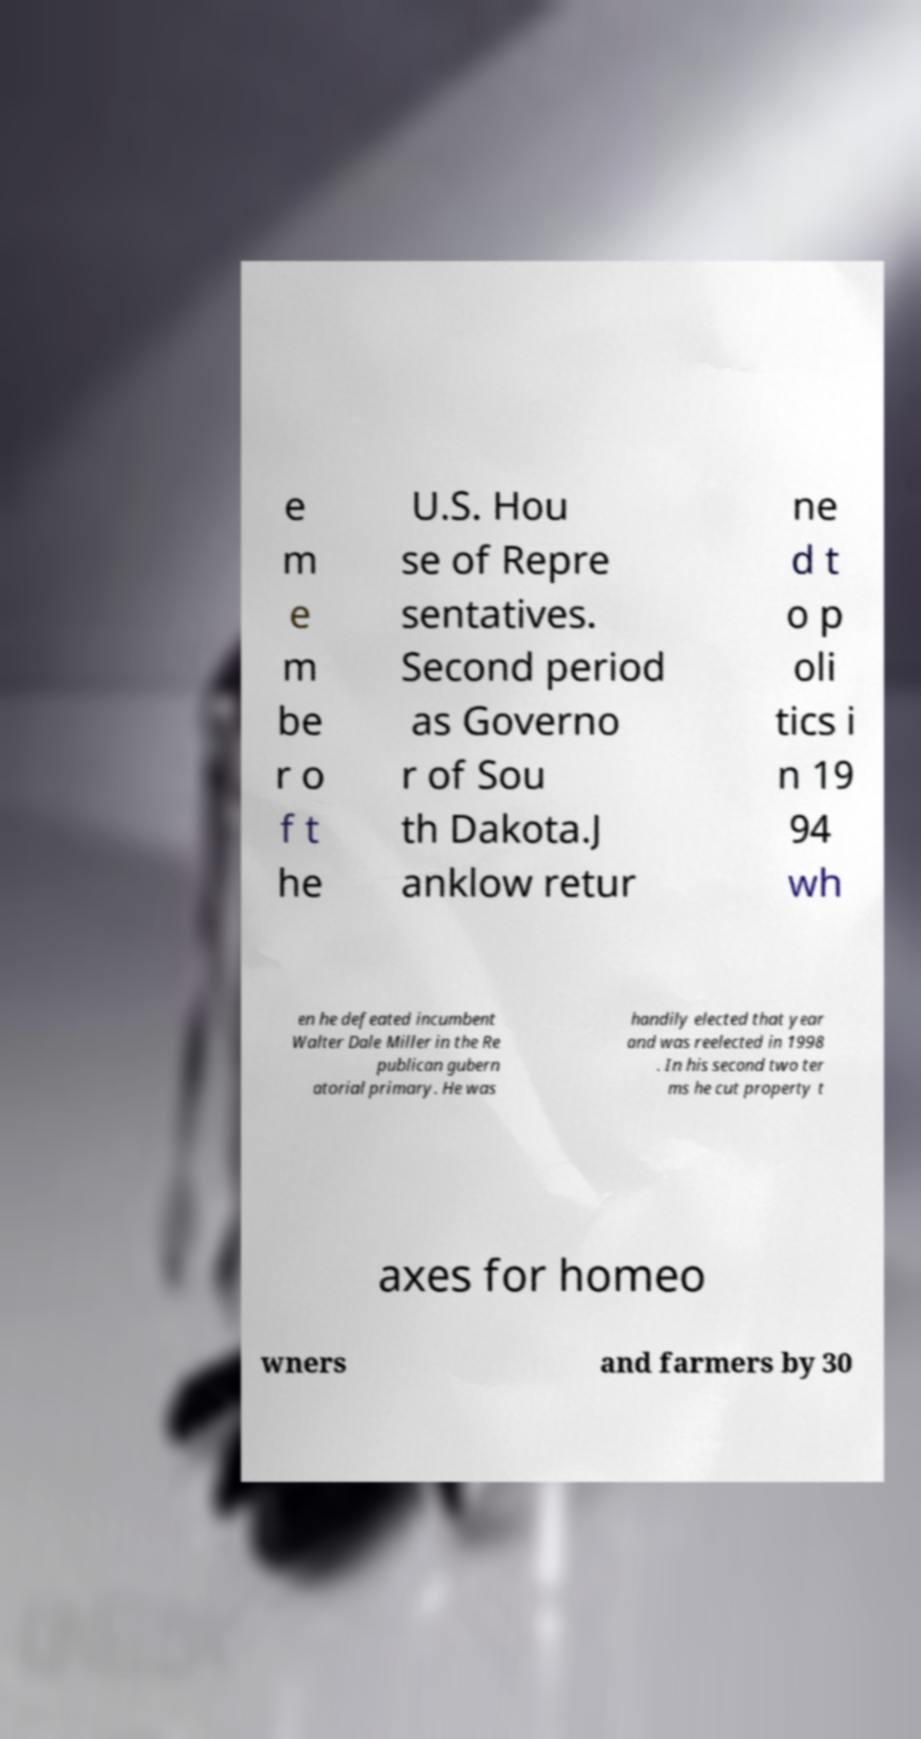What messages or text are displayed in this image? I need them in a readable, typed format. e m e m be r o f t he U.S. Hou se of Repre sentatives. Second period as Governo r of Sou th Dakota.J anklow retur ne d t o p oli tics i n 19 94 wh en he defeated incumbent Walter Dale Miller in the Re publican gubern atorial primary. He was handily elected that year and was reelected in 1998 . In his second two ter ms he cut property t axes for homeo wners and farmers by 30 